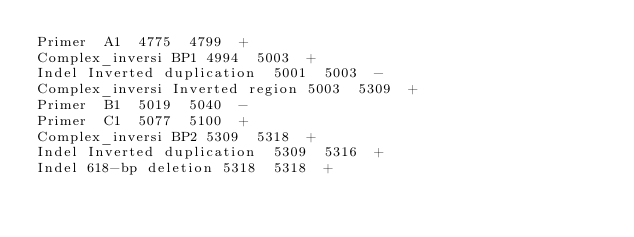Convert code to text. <code><loc_0><loc_0><loc_500><loc_500><_SQL_>Primer	A1	4775	4799	+
Complex_inversi	BP1	4994	5003	+
Indel	Inverted duplication	5001	5003	-
Complex_inversi	Inverted region	5003	5309	+
Primer	B1	5019	5040	-
Primer	C1	5077	5100	+
Complex_inversi	BP2	5309	5318	+
Indel	Inverted duplication	5309	5316	+
Indel	618-bp deletion	5318	5318	+
</code> 